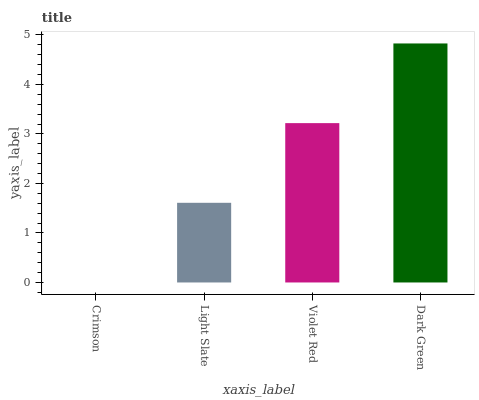Is Crimson the minimum?
Answer yes or no. Yes. Is Dark Green the maximum?
Answer yes or no. Yes. Is Light Slate the minimum?
Answer yes or no. No. Is Light Slate the maximum?
Answer yes or no. No. Is Light Slate greater than Crimson?
Answer yes or no. Yes. Is Crimson less than Light Slate?
Answer yes or no. Yes. Is Crimson greater than Light Slate?
Answer yes or no. No. Is Light Slate less than Crimson?
Answer yes or no. No. Is Violet Red the high median?
Answer yes or no. Yes. Is Light Slate the low median?
Answer yes or no. Yes. Is Crimson the high median?
Answer yes or no. No. Is Violet Red the low median?
Answer yes or no. No. 